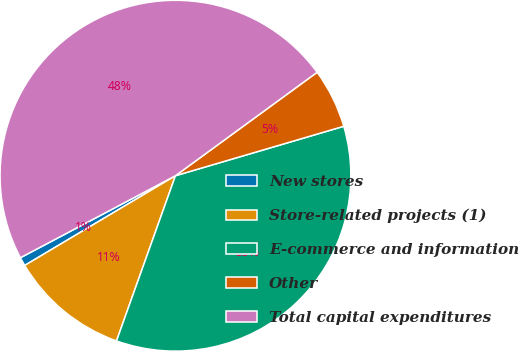Convert chart to OTSL. <chart><loc_0><loc_0><loc_500><loc_500><pie_chart><fcel>New stores<fcel>Store-related projects (1)<fcel>E-commerce and information<fcel>Other<fcel>Total capital expenditures<nl><fcel>0.8%<fcel>11.0%<fcel>35.0%<fcel>5.49%<fcel>47.7%<nl></chart> 